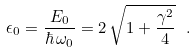<formula> <loc_0><loc_0><loc_500><loc_500>\epsilon _ { 0 } = \frac { E _ { 0 } } { \hbar { \, } \omega _ { 0 } } = 2 \, \sqrt { 1 + \frac { \gamma ^ { 2 } } { 4 } } \ .</formula> 